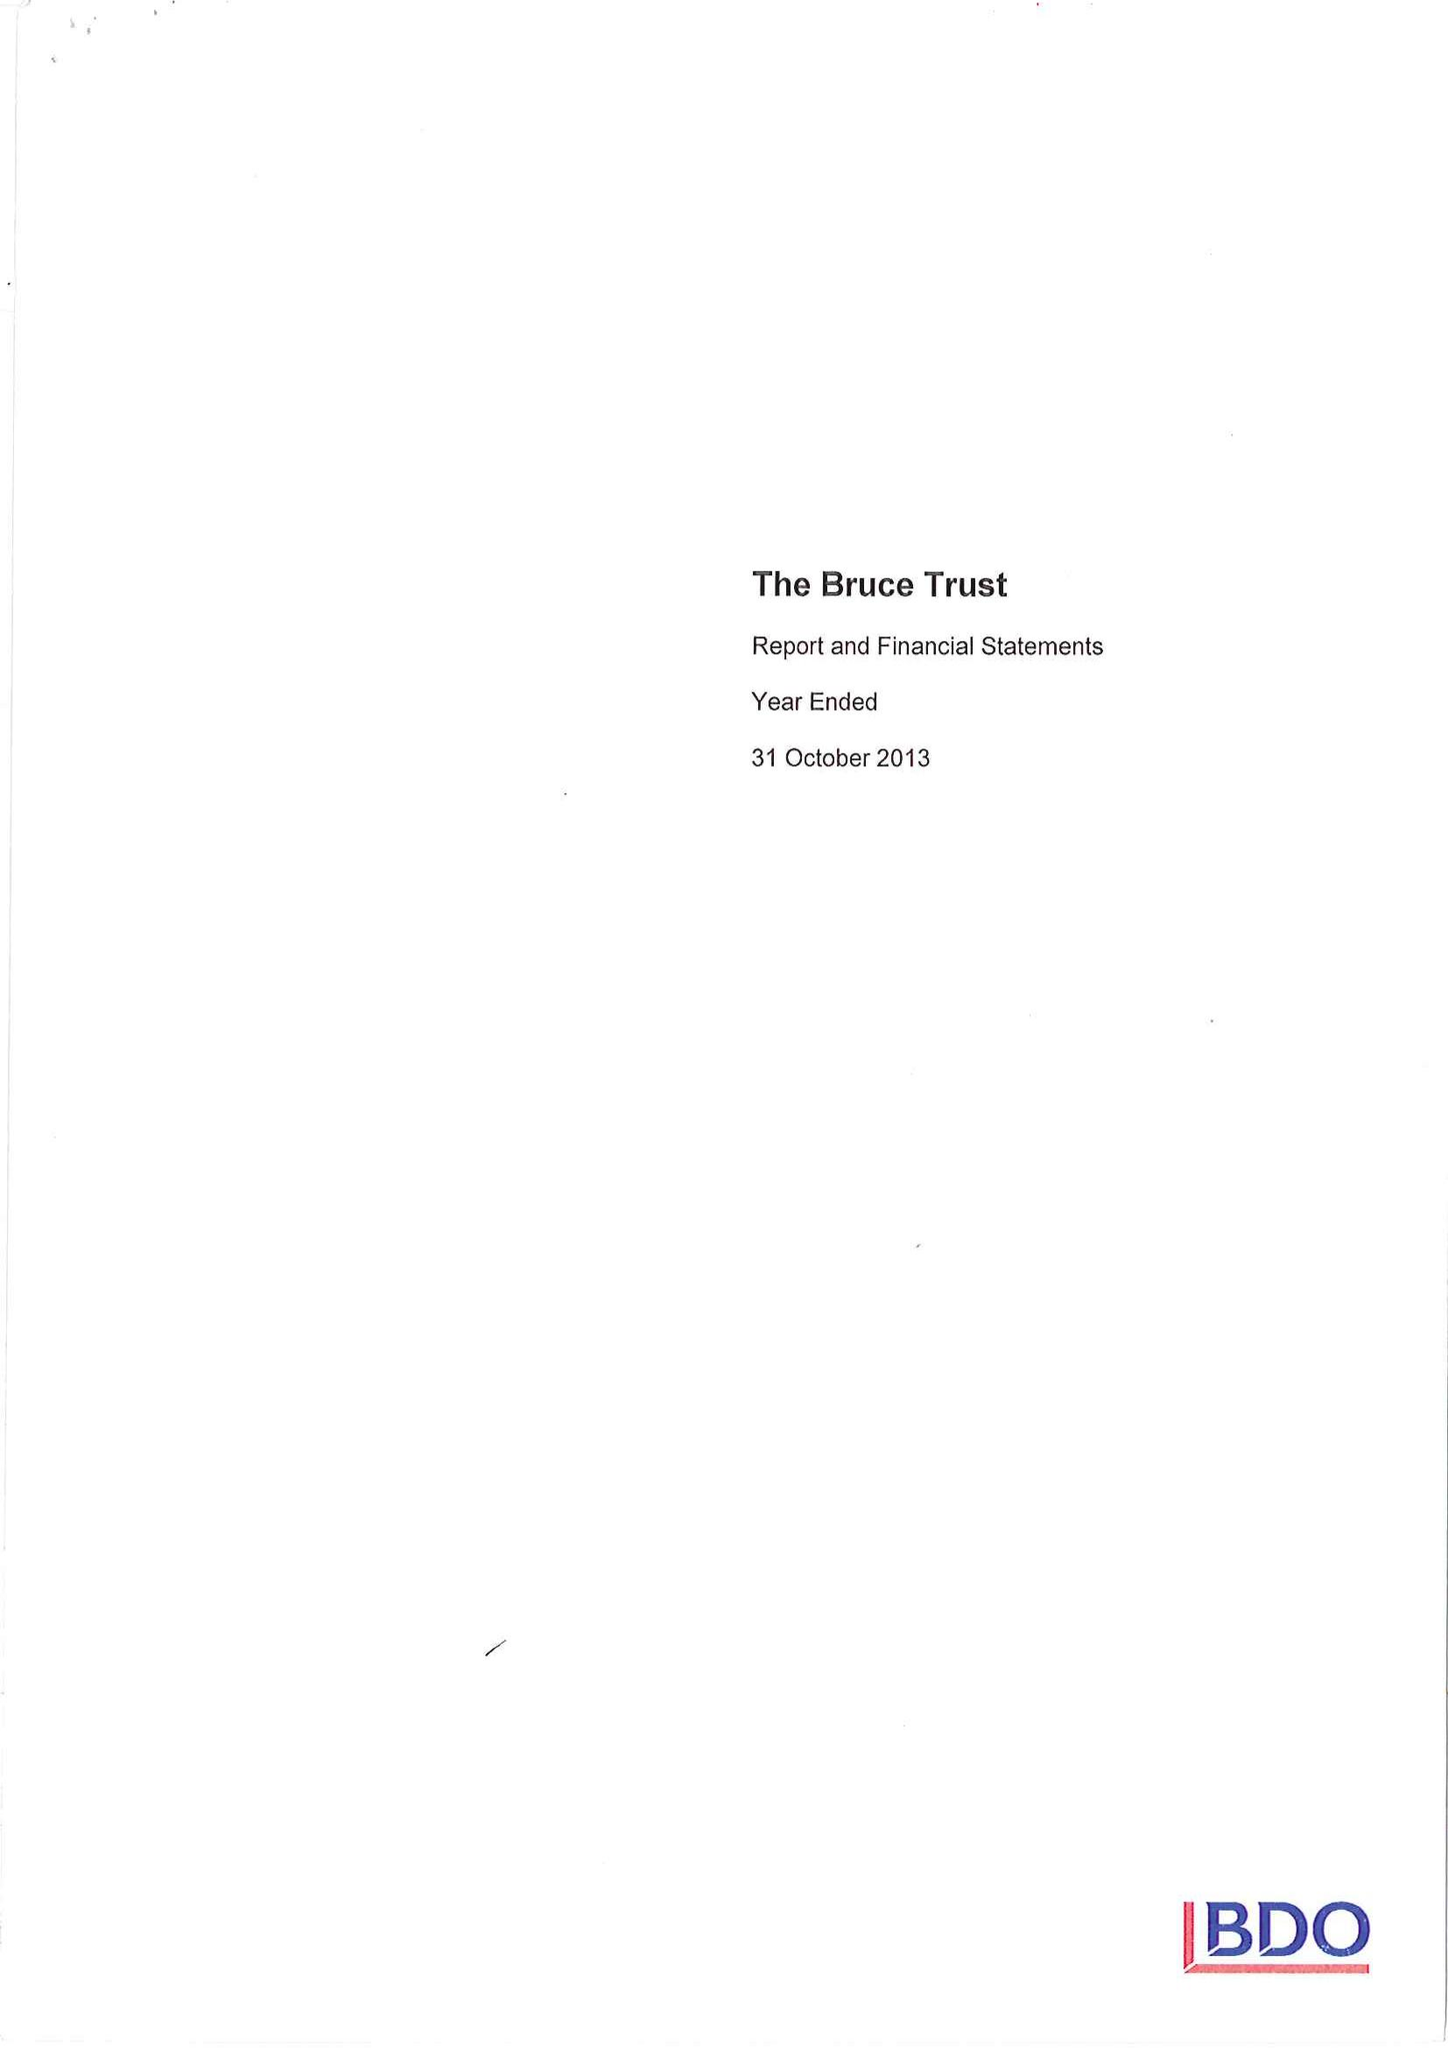What is the value for the report_date?
Answer the question using a single word or phrase. 2013-10-31 